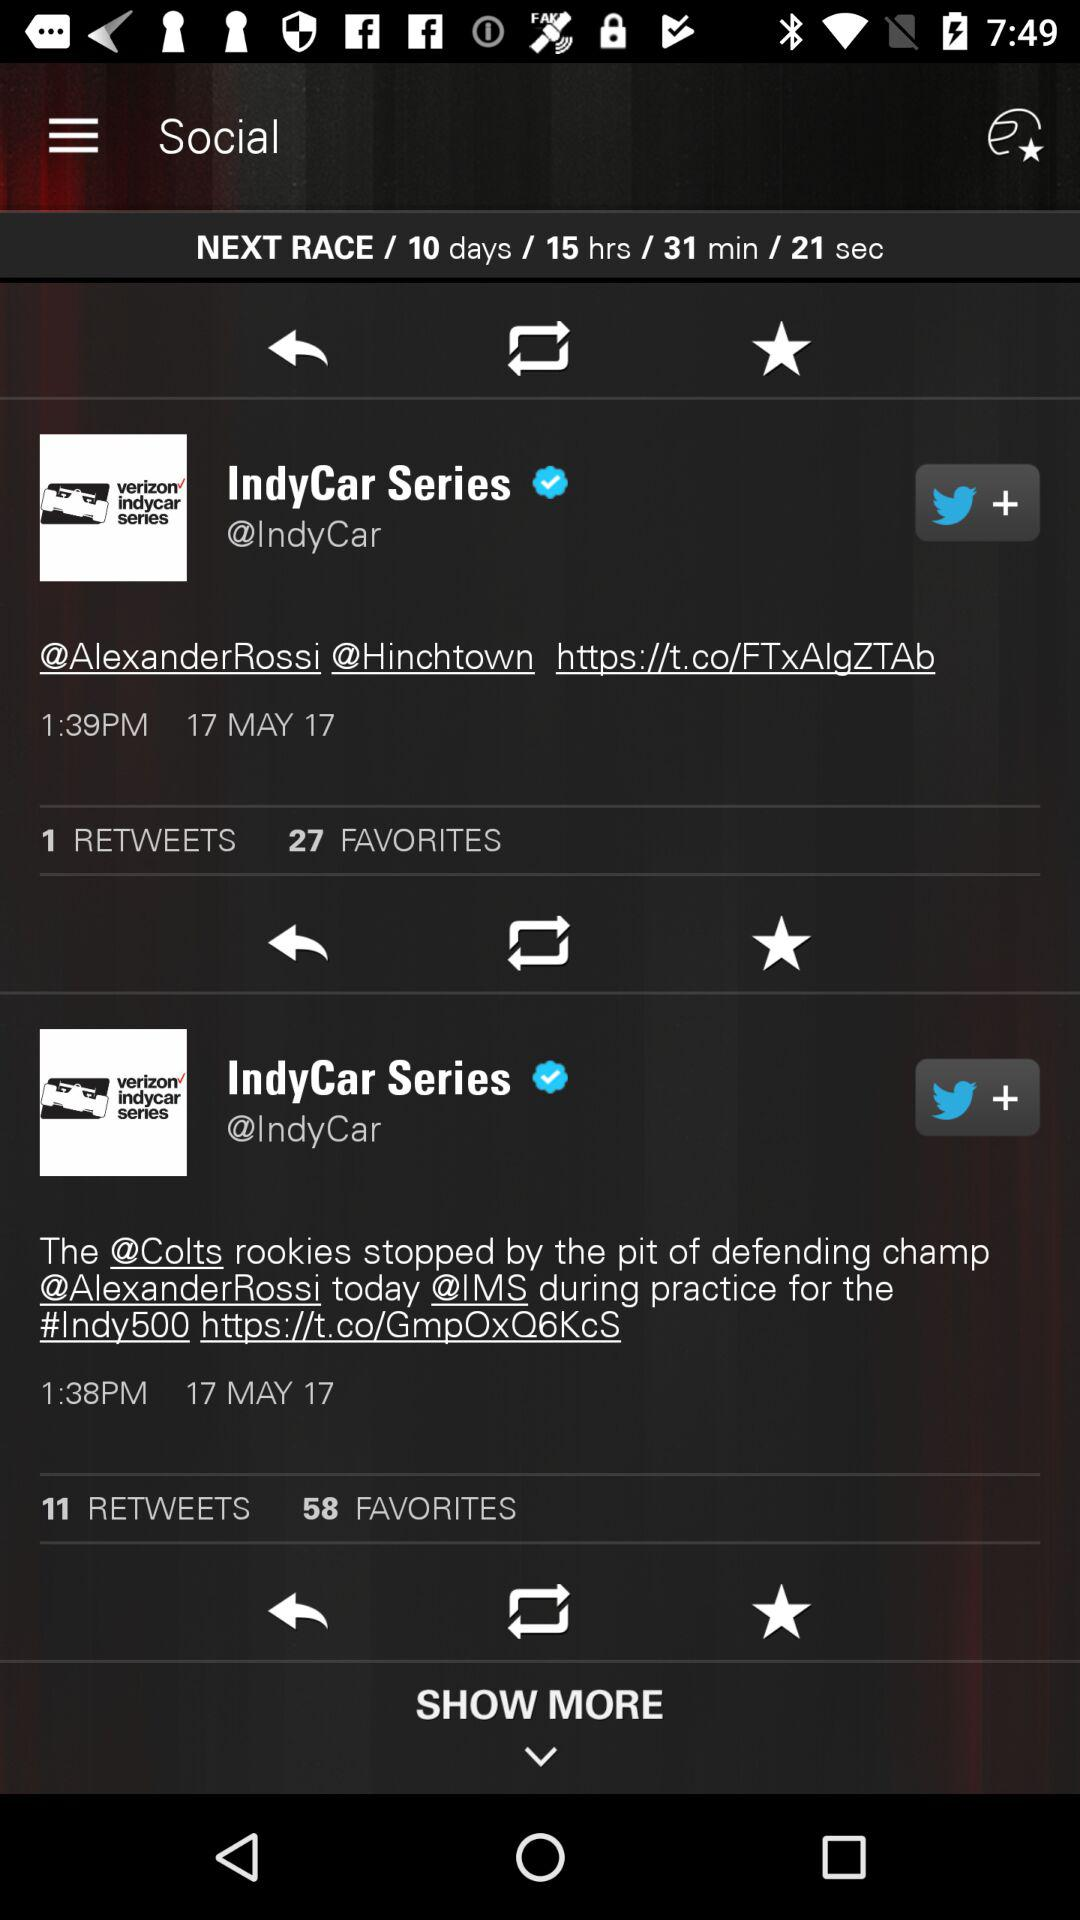How many retweets are there for the tweet done at 1:39 PM? There is 1 retweet for the tweet done at 1:39 PM. 